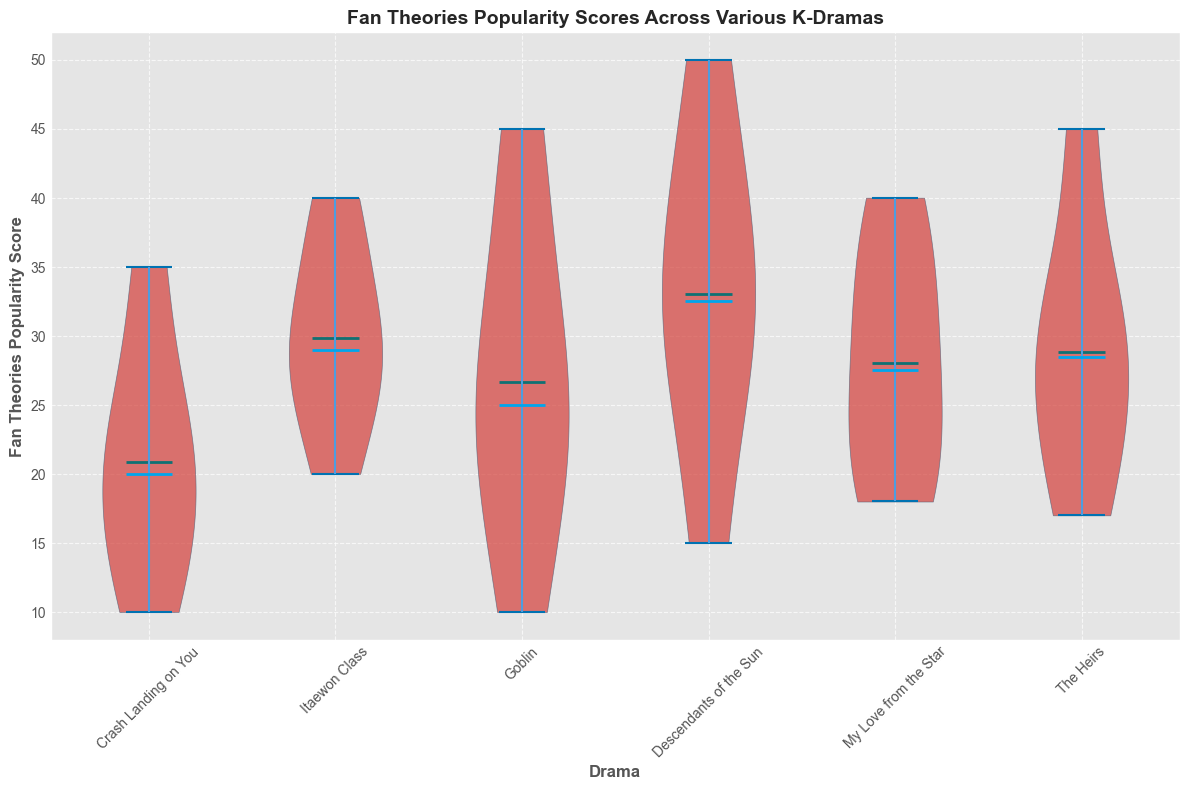What drama has the highest median popularity score? The violin plot shows median lines for each drama. We observe the median line for "Descendants of the Sun" is placed highest compared to other dramas.
Answer: Descendants of the Sun Which drama has the lowest mean popularity score? The violin plot indicates the mean line in green for each drama. The lowest mean line visibly corresponds to "Crash Landing on You".
Answer: Crash Landing on You Compare the median popularity scores between "Itaewon Class" and "Goblin". Which one is higher? By observing the median lines in the violin plot, "Goblin" has a higher positioned median line compared to "Itaewon Class".
Answer: Goblin What is the range of popularity scores for "The Heirs"? The range for "The Heirs" can be determined by looking at the top and bottom ends of the violin plot tail for this drama. The scores range approximately from 17 to 45.
Answer: 17 to 45 Which drama has the widest spread of popularity scores? The width of the violins represents the spread of scores. "The Heirs" appears to have the widest span from lowest to highest score.
Answer: The Heirs Rank the dramas in order of their highest observed popularity score. Observing the topmost points of each violin plot, the highest scores are: Descendants of the Sun > The Heirs > Goblin > Itaewon Class > My Love from the Star > Crash Landing on You.
Answer: Descendants of the Sun, The Heirs, Goblin, Itaewon Class, My Love from the Star, Crash Landing on You Which drama has the most concentrated popularity scores around the median? Concentration around the median can be visualized as the narrowness around the median line. "Goblin" seems to have the most narrow region around its median line.
Answer: Goblin Compare the mean popularity scores of "My Love from the Star" and "Crash Landing on You". By looking at the green mean lines, "My Love from the Star" has a higher mean score compared to "Crash Landing on You".
Answer: My Love from the Star 